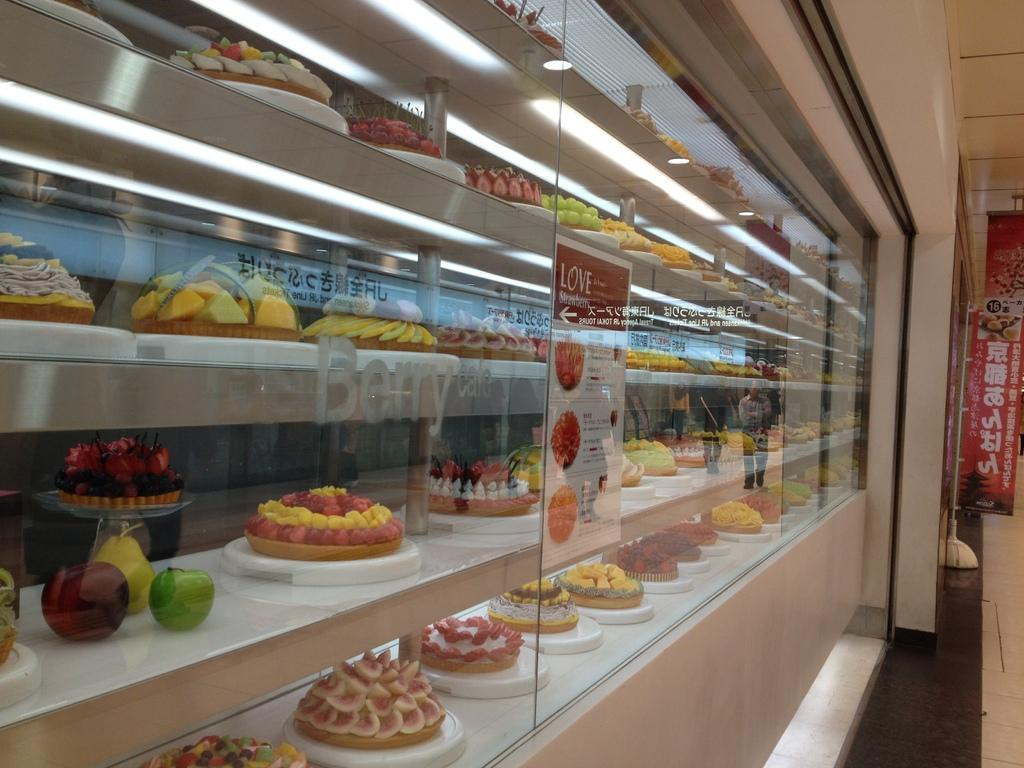<image>
Create a compact narrative representing the image presented. Cakes behind a glass and a sign that says Love. 